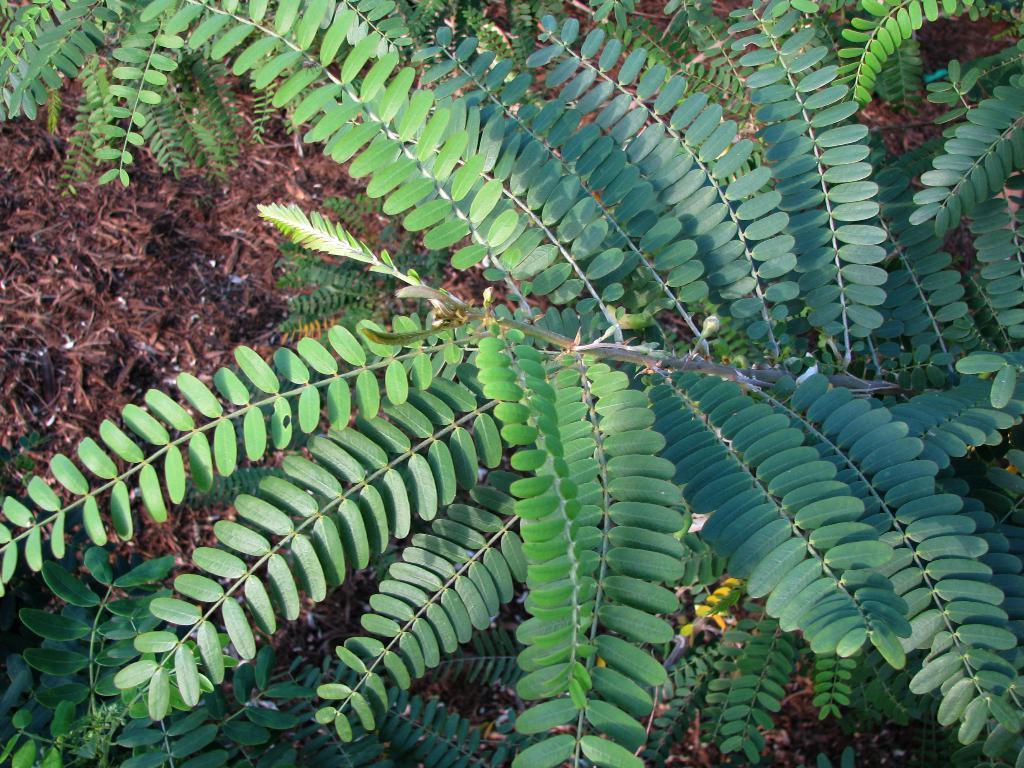Could you give a brief overview of what you see in this image? In this picture, we see a tree. On the left side, we see the twigs of the soil and it is in brown color. 